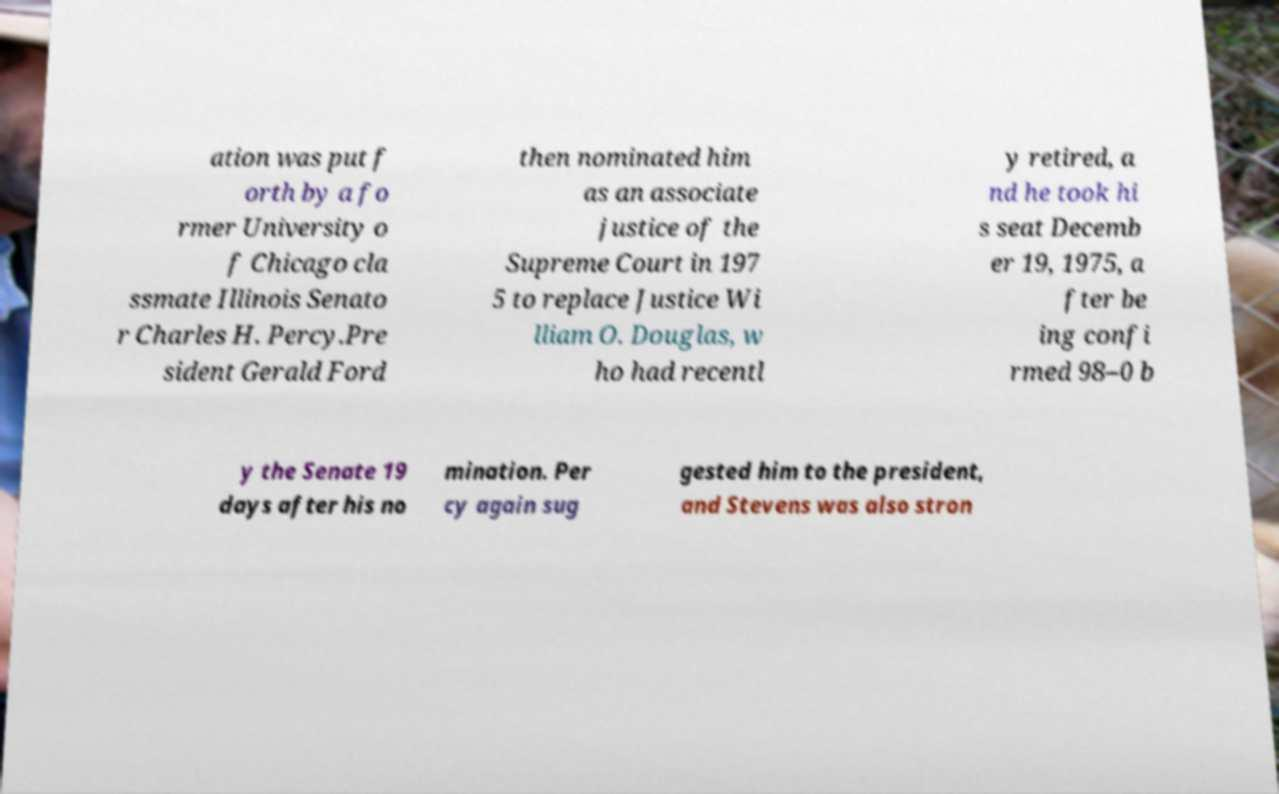Can you read and provide the text displayed in the image?This photo seems to have some interesting text. Can you extract and type it out for me? ation was put f orth by a fo rmer University o f Chicago cla ssmate Illinois Senato r Charles H. Percy.Pre sident Gerald Ford then nominated him as an associate justice of the Supreme Court in 197 5 to replace Justice Wi lliam O. Douglas, w ho had recentl y retired, a nd he took hi s seat Decemb er 19, 1975, a fter be ing confi rmed 98–0 b y the Senate 19 days after his no mination. Per cy again sug gested him to the president, and Stevens was also stron 